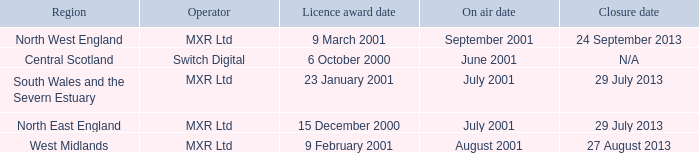What is the license award date for North East England? 15 December 2000. 